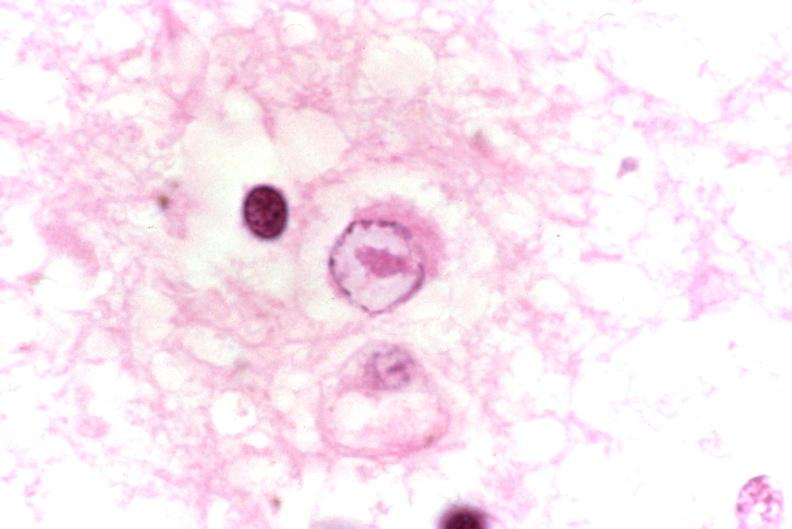where is this?
Answer the question using a single word or phrase. Nervous 